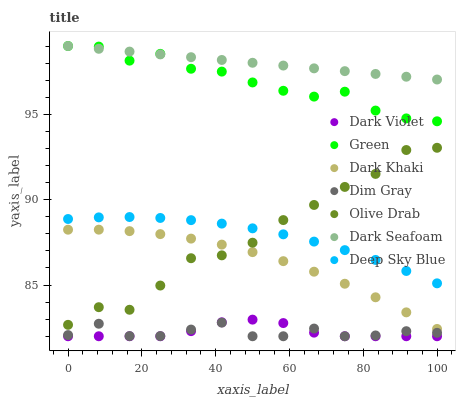Does Dim Gray have the minimum area under the curve?
Answer yes or no. Yes. Does Dark Seafoam have the maximum area under the curve?
Answer yes or no. Yes. Does Dark Violet have the minimum area under the curve?
Answer yes or no. No. Does Dark Violet have the maximum area under the curve?
Answer yes or no. No. Is Dark Seafoam the smoothest?
Answer yes or no. Yes. Is Olive Drab the roughest?
Answer yes or no. Yes. Is Dark Violet the smoothest?
Answer yes or no. No. Is Dark Violet the roughest?
Answer yes or no. No. Does Dim Gray have the lowest value?
Answer yes or no. Yes. Does Dark Khaki have the lowest value?
Answer yes or no. No. Does Green have the highest value?
Answer yes or no. Yes. Does Dark Violet have the highest value?
Answer yes or no. No. Is Dark Khaki less than Green?
Answer yes or no. Yes. Is Green greater than Dark Khaki?
Answer yes or no. Yes. Does Green intersect Dark Seafoam?
Answer yes or no. Yes. Is Green less than Dark Seafoam?
Answer yes or no. No. Is Green greater than Dark Seafoam?
Answer yes or no. No. Does Dark Khaki intersect Green?
Answer yes or no. No. 